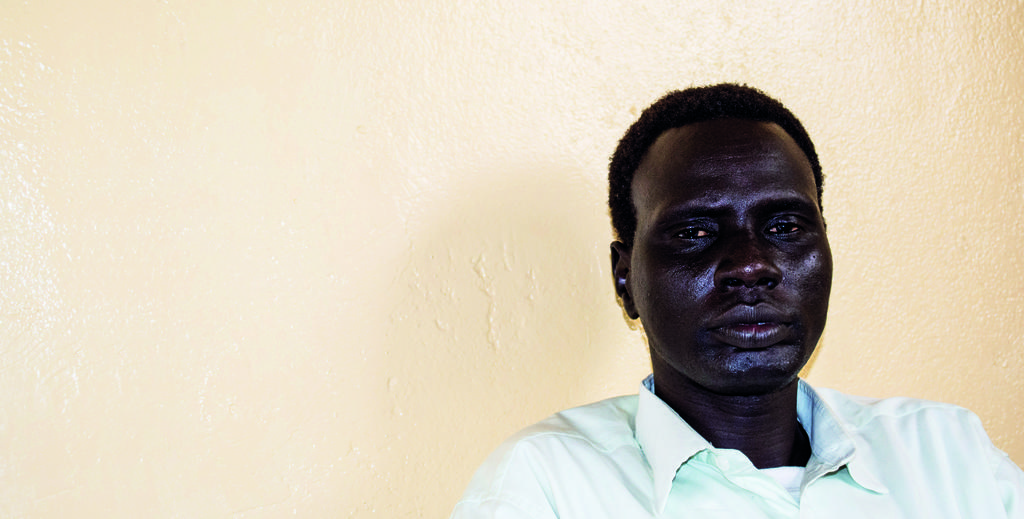Who is present in the image? There is a man in the image. What is the man wearing? The man is wearing a shirt. What can be seen in the background of the image? There is a wall in the background of the image. What type of milk is the man holding in the image? There is no milk present in the image; the man is not holding anything. 